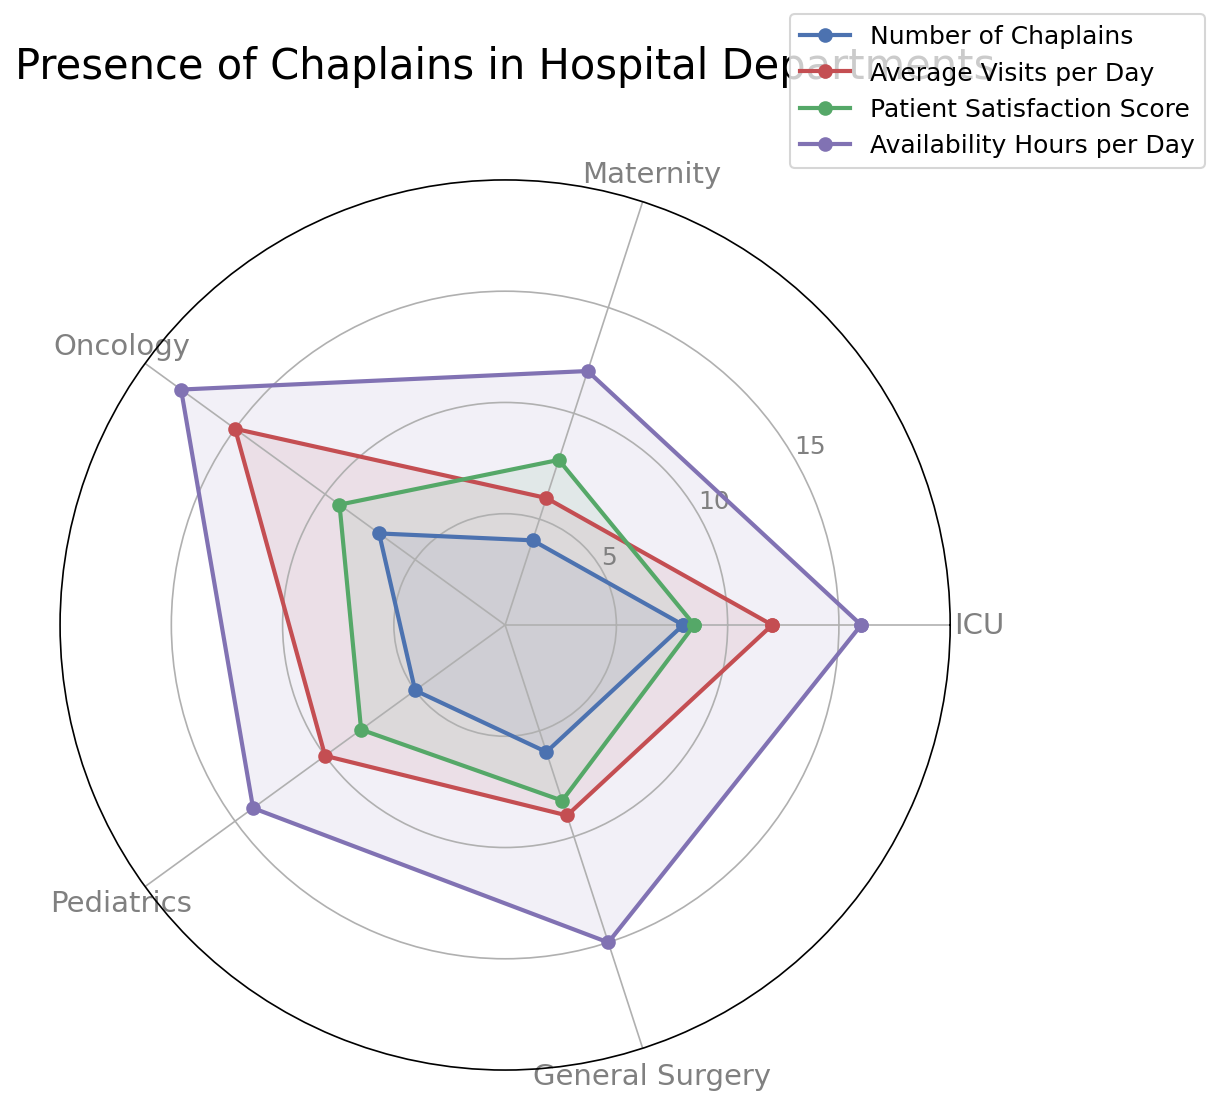Which department has the highest number of chaplains? Compare the length of lines (or positions of markers) along the "Number of Chaplains" axis. The department with the highest marker is ICU with the value of 8.
Answer: ICU Which department has the lowest patient satisfaction score? Look at the "Patient Satisfaction Score" axis and identify the department with the shortest line or lowest marker position, which is Maternity with a score of 7.8.
Answer: Maternity How does the average number of visits per day in Oncology compare to Pediatrics? Compare the length of lines (positions of markers) along the "Average Visits per Day" axis for Oncology and Pediatrics. Oncology has 15 visits, and Pediatrics has 10.
Answer: Oncology > Pediatrics What is the combined total of availability hours per day for ICU and General Surgery? Add the "Availability Hours per Day" values for ICU (16) and General Surgery (15). 16 + 15 = 31
Answer: 31 Which department's chaplains have the highest average visits per day? Check the "Average Visits per Day" axis and identify the department with the highest value; it's Oncology with 15 visits.
Answer: Oncology Is the patient satisfaction score higher in Pediatrics or in General Surgery? Compare the patient satisfaction scores in Pediatrics (8.0) and General Surgery (8.3). General Surgery has a higher score.
Answer: General Surgery What are the total number of chaplains in ICU, Maternity, and Pediatrics combined? Add the "Number of Chaplains" for ICU (8), Maternity (4), and Pediatrics (5). 8 + 4 + 5 = 17
Answer: 17 Which department has the most balanced presence across all metrics? A balanced presence implies relatively similar values across all categories on the radar chart. General Surgery has a well-distributed presence across different metrics (Number of Chaplains, Average Visits per Day, Patient Satisfaction Score, and Availability Hours per Day).
Answer: General Surgery 